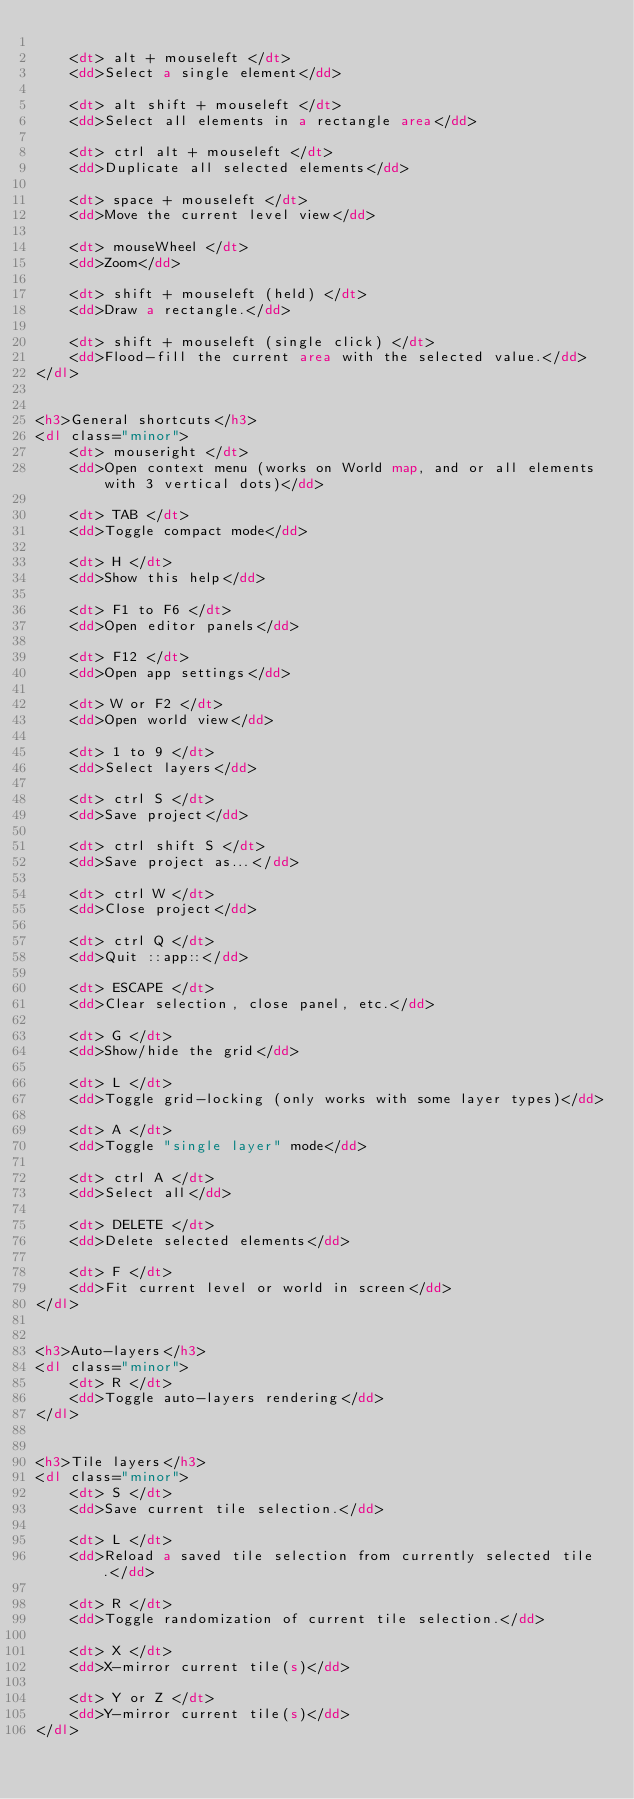<code> <loc_0><loc_0><loc_500><loc_500><_HTML_>
	<dt> alt + mouseleft </dt>
	<dd>Select a single element</dd>

	<dt> alt shift + mouseleft </dt>
	<dd>Select all elements in a rectangle area</dd>

	<dt> ctrl alt + mouseleft </dt>
	<dd>Duplicate all selected elements</dd>

	<dt> space + mouseleft </dt>
	<dd>Move the current level view</dd>

	<dt> mouseWheel </dt>
	<dd>Zoom</dd>

	<dt> shift + mouseleft (held) </dt>
	<dd>Draw a rectangle.</dd>

	<dt> shift + mouseleft (single click) </dt>
	<dd>Flood-fill the current area with the selected value.</dd>
</dl>


<h3>General shortcuts</h3>
<dl class="minor">
	<dt> mouseright </dt>
	<dd>Open context menu (works on World map, and or all elements with 3 vertical dots)</dd>

	<dt> TAB </dt>
	<dd>Toggle compact mode</dd>

	<dt> H </dt>
	<dd>Show this help</dd>

	<dt> F1 to F6 </dt>
	<dd>Open editor panels</dd>

	<dt> F12 </dt>
	<dd>Open app settings</dd>

	<dt> W or F2 </dt>
	<dd>Open world view</dd>

	<dt> 1 to 9 </dt>
	<dd>Select layers</dd>

	<dt> ctrl S </dt>
	<dd>Save project</dd>

	<dt> ctrl shift S </dt>
	<dd>Save project as...</dd>

	<dt> ctrl W </dt>
	<dd>Close project</dd>

	<dt> ctrl Q </dt>
	<dd>Quit ::app::</dd>

	<dt> ESCAPE </dt>
	<dd>Clear selection, close panel, etc.</dd>

	<dt> G </dt>
	<dd>Show/hide the grid</dd>

	<dt> L </dt>
	<dd>Toggle grid-locking (only works with some layer types)</dd>

	<dt> A </dt>
	<dd>Toggle "single layer" mode</dd>

	<dt> ctrl A </dt>
	<dd>Select all</dd>

	<dt> DELETE </dt>
	<dd>Delete selected elements</dd>

	<dt> F </dt>
	<dd>Fit current level or world in screen</dd>
</dl>


<h3>Auto-layers</h3>
<dl class="minor">
	<dt> R </dt>
	<dd>Toggle auto-layers rendering</dd>
</dl>


<h3>Tile layers</h3>
<dl class="minor">
	<dt> S </dt>
	<dd>Save current tile selection.</dd>

	<dt> L </dt>
	<dd>Reload a saved tile selection from currently selected tile.</dd>

	<dt> R </dt>
	<dd>Toggle randomization of current tile selection.</dd>

	<dt> X </dt>
	<dd>X-mirror current tile(s)</dd>

	<dt> Y or Z </dt>
	<dd>Y-mirror current tile(s)</dd>
</dl>

</code> 